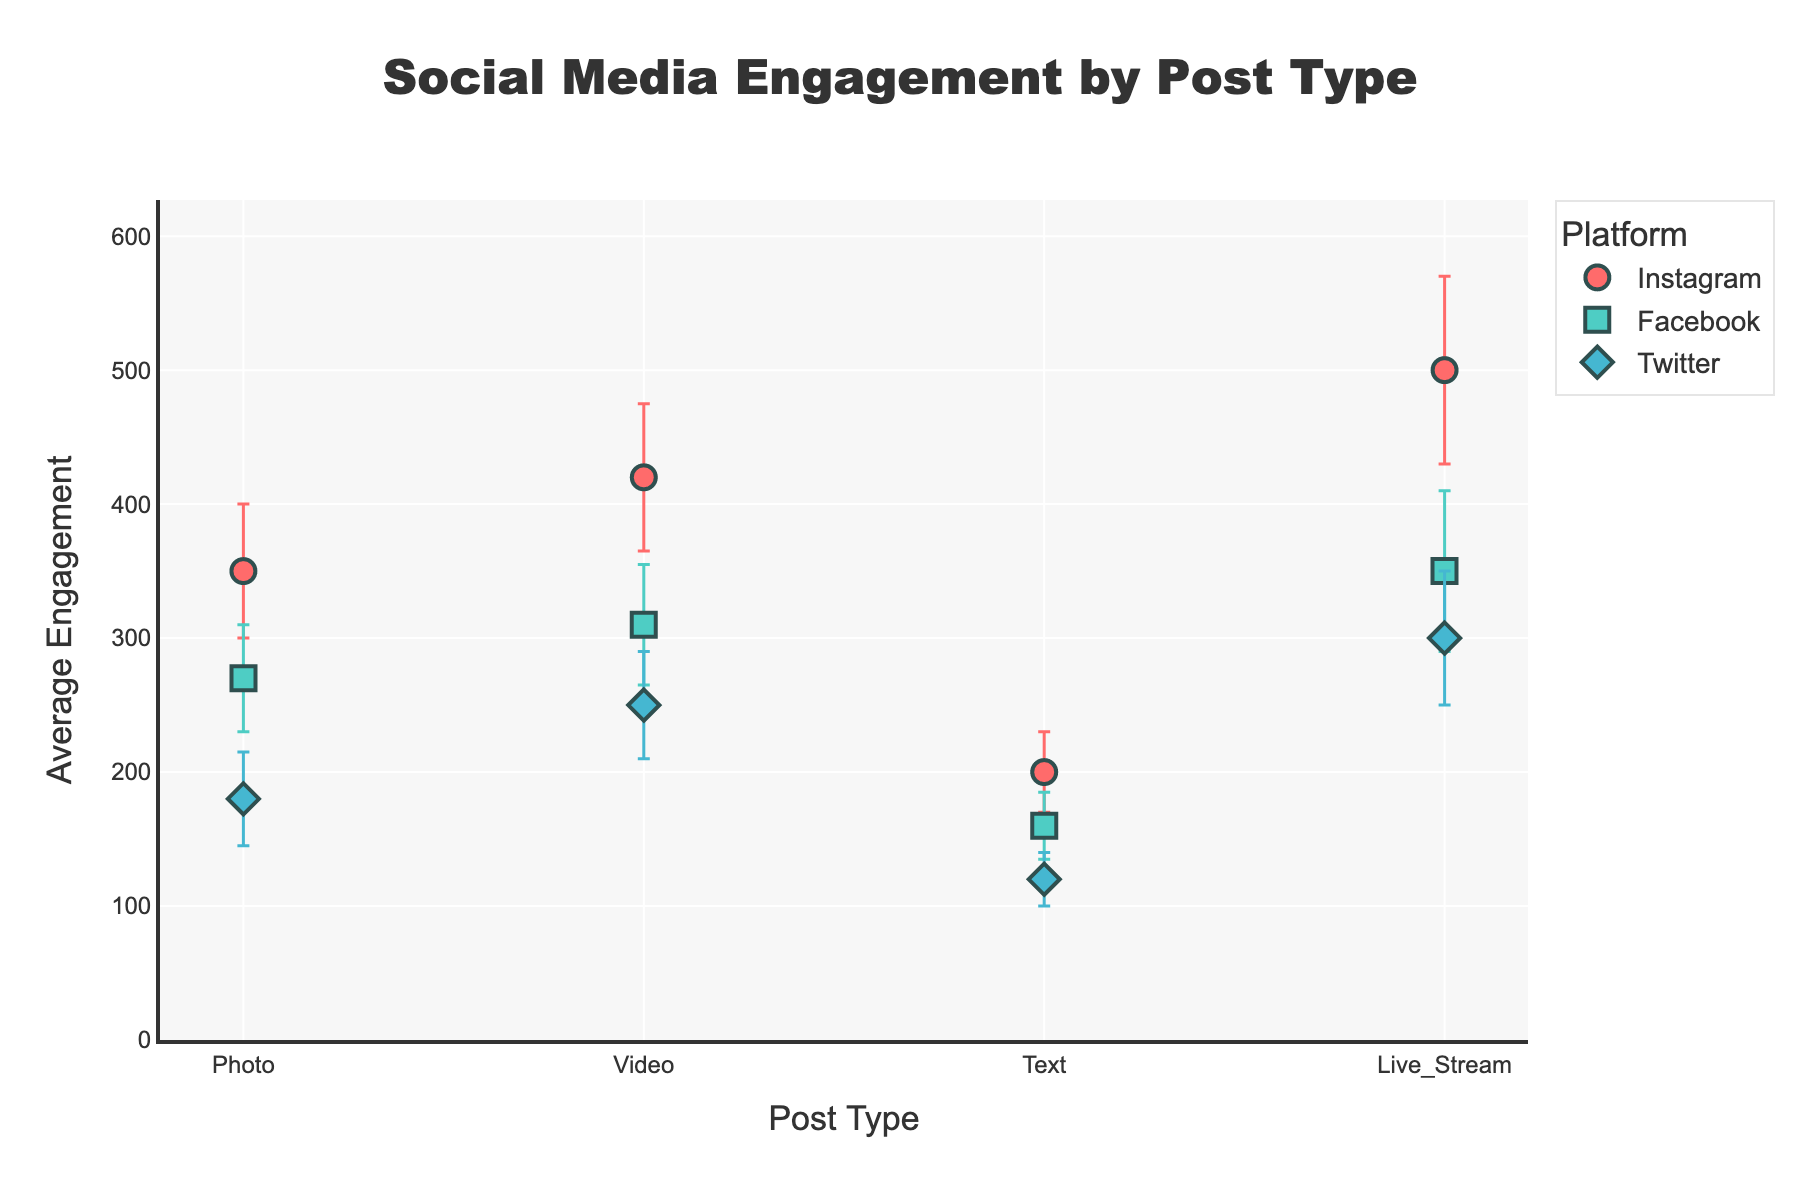What's the title of the figure? The title of the figure is usually displayed at the top center. In this case, the title is "Social Media Engagement by Post Type".
Answer: Social Media Engagement by Post Type Which post type has the highest average engagement on Instagram? To determine this, look at the data points along the "Post Type" axis for Instagram. The highest value for "Average Engagement" on Instagram is for "Live_Stream".
Answer: Live_Stream How much higher is the average engagement for Live_Stream on Facebook compared to Text on Facebook? Look at the "Average Engagement" for "Live_Stream" on Facebook and "Text" on Facebook. The values are 350 and 160, respectively. Calculate the difference: 350 - 160.
Answer: 190 Which platform shows the smallest variability (standard deviation) for Photos? Examine the error bars on the dots for the "Photo" post type across platforms. The platform with the shortest error bar for "Photo" is Facebook, which has a standard deviation of 40.
Answer: Facebook What is the range of average engagement values for Videos across all platforms? Look at the "Average Engagement" values for the "Video" post type across Instagram, Facebook, and Twitter. The values are 420, 310, and 250. The range is from the minimum (250) to the maximum (420).
Answer: 250 to 420 Which platform has the largest average engagement for Text posts, and what is the value? Check the "Average Engagement" values for "Text" posts across all platforms. Instagram has the highest value at 200.
Answer: Instagram, 200 What post type and platform combination has the smallest reported engagement, and what value does it have? To find this, scan all data points and their "Average Engagement". The smallest value is 120 for "Text" on Twitter.
Answer: Text on Twitter, 120 On which platform do Live_Stream posts have the largest error bars, indicating the highest variability? Look at the length of the error bars for "Live_Stream" across platforms. The longest error bars are for Instagram, which has a standard deviation of 70.
Answer: Instagram Calculate the average engagement for Photos across all platforms. The "Average Engagement" values for "Photos" are 350 (Instagram), 270 (Facebook), and 180 (Twitter). Calculate the average: (350 + 270 + 180) / 3.
Answer: 266.67 Which two Post Types show the largest difference in average engagement on Twitter, and what is the difference? Check the "Average Engagement" for all post types on Twitter: Photo (180), Video (250), Text (120), and Live_Stream (300). The largest difference is between Live_Stream and Text: 300 - 120.
Answer: Live_Stream and Text, 180 